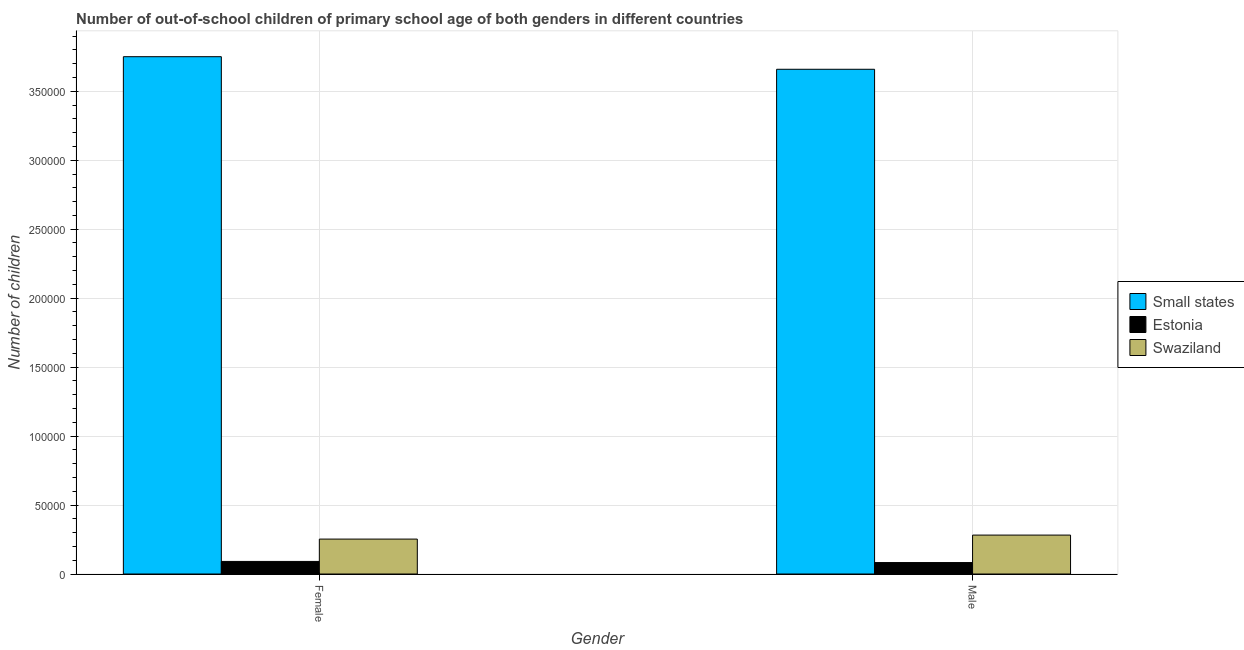How many bars are there on the 2nd tick from the left?
Your response must be concise. 3. How many bars are there on the 1st tick from the right?
Offer a very short reply. 3. What is the label of the 1st group of bars from the left?
Provide a succinct answer. Female. What is the number of male out-of-school students in Small states?
Provide a succinct answer. 3.66e+05. Across all countries, what is the maximum number of female out-of-school students?
Ensure brevity in your answer.  3.75e+05. Across all countries, what is the minimum number of female out-of-school students?
Offer a terse response. 9112. In which country was the number of female out-of-school students maximum?
Your response must be concise. Small states. In which country was the number of female out-of-school students minimum?
Offer a very short reply. Estonia. What is the total number of female out-of-school students in the graph?
Your response must be concise. 4.10e+05. What is the difference between the number of male out-of-school students in Estonia and that in Small states?
Your answer should be compact. -3.58e+05. What is the difference between the number of female out-of-school students in Swaziland and the number of male out-of-school students in Estonia?
Your answer should be compact. 1.70e+04. What is the average number of female out-of-school students per country?
Your answer should be very brief. 1.37e+05. What is the difference between the number of male out-of-school students and number of female out-of-school students in Estonia?
Provide a short and direct response. -815. What is the ratio of the number of male out-of-school students in Small states to that in Estonia?
Keep it short and to the point. 44.11. Is the number of male out-of-school students in Estonia less than that in Swaziland?
Make the answer very short. Yes. In how many countries, is the number of male out-of-school students greater than the average number of male out-of-school students taken over all countries?
Provide a succinct answer. 1. What does the 1st bar from the left in Female represents?
Your answer should be very brief. Small states. What does the 3rd bar from the right in Male represents?
Provide a succinct answer. Small states. How many countries are there in the graph?
Your answer should be very brief. 3. What is the difference between two consecutive major ticks on the Y-axis?
Offer a very short reply. 5.00e+04. Does the graph contain grids?
Ensure brevity in your answer.  Yes. How are the legend labels stacked?
Offer a very short reply. Vertical. What is the title of the graph?
Offer a terse response. Number of out-of-school children of primary school age of both genders in different countries. Does "Pakistan" appear as one of the legend labels in the graph?
Give a very brief answer. No. What is the label or title of the X-axis?
Offer a very short reply. Gender. What is the label or title of the Y-axis?
Offer a terse response. Number of children. What is the Number of children of Small states in Female?
Provide a succinct answer. 3.75e+05. What is the Number of children of Estonia in Female?
Keep it short and to the point. 9112. What is the Number of children in Swaziland in Female?
Provide a short and direct response. 2.53e+04. What is the Number of children in Small states in Male?
Make the answer very short. 3.66e+05. What is the Number of children in Estonia in Male?
Keep it short and to the point. 8297. What is the Number of children of Swaziland in Male?
Offer a very short reply. 2.82e+04. Across all Gender, what is the maximum Number of children in Small states?
Ensure brevity in your answer.  3.75e+05. Across all Gender, what is the maximum Number of children in Estonia?
Your answer should be very brief. 9112. Across all Gender, what is the maximum Number of children in Swaziland?
Your response must be concise. 2.82e+04. Across all Gender, what is the minimum Number of children in Small states?
Keep it short and to the point. 3.66e+05. Across all Gender, what is the minimum Number of children of Estonia?
Keep it short and to the point. 8297. Across all Gender, what is the minimum Number of children in Swaziland?
Make the answer very short. 2.53e+04. What is the total Number of children of Small states in the graph?
Provide a short and direct response. 7.41e+05. What is the total Number of children of Estonia in the graph?
Make the answer very short. 1.74e+04. What is the total Number of children of Swaziland in the graph?
Offer a very short reply. 5.35e+04. What is the difference between the Number of children of Small states in Female and that in Male?
Give a very brief answer. 9123. What is the difference between the Number of children of Estonia in Female and that in Male?
Your response must be concise. 815. What is the difference between the Number of children of Swaziland in Female and that in Male?
Provide a succinct answer. -2902. What is the difference between the Number of children of Small states in Female and the Number of children of Estonia in Male?
Your response must be concise. 3.67e+05. What is the difference between the Number of children of Small states in Female and the Number of children of Swaziland in Male?
Give a very brief answer. 3.47e+05. What is the difference between the Number of children of Estonia in Female and the Number of children of Swaziland in Male?
Give a very brief answer. -1.91e+04. What is the average Number of children in Small states per Gender?
Your answer should be compact. 3.71e+05. What is the average Number of children of Estonia per Gender?
Your answer should be compact. 8704.5. What is the average Number of children of Swaziland per Gender?
Your answer should be compact. 2.68e+04. What is the difference between the Number of children of Small states and Number of children of Estonia in Female?
Provide a short and direct response. 3.66e+05. What is the difference between the Number of children of Small states and Number of children of Swaziland in Female?
Your response must be concise. 3.50e+05. What is the difference between the Number of children of Estonia and Number of children of Swaziland in Female?
Keep it short and to the point. -1.62e+04. What is the difference between the Number of children of Small states and Number of children of Estonia in Male?
Your answer should be compact. 3.58e+05. What is the difference between the Number of children in Small states and Number of children in Swaziland in Male?
Your response must be concise. 3.38e+05. What is the difference between the Number of children of Estonia and Number of children of Swaziland in Male?
Offer a terse response. -1.99e+04. What is the ratio of the Number of children of Small states in Female to that in Male?
Provide a short and direct response. 1.02. What is the ratio of the Number of children of Estonia in Female to that in Male?
Offer a very short reply. 1.1. What is the ratio of the Number of children in Swaziland in Female to that in Male?
Keep it short and to the point. 0.9. What is the difference between the highest and the second highest Number of children in Small states?
Provide a succinct answer. 9123. What is the difference between the highest and the second highest Number of children of Estonia?
Your answer should be compact. 815. What is the difference between the highest and the second highest Number of children in Swaziland?
Your response must be concise. 2902. What is the difference between the highest and the lowest Number of children in Small states?
Keep it short and to the point. 9123. What is the difference between the highest and the lowest Number of children in Estonia?
Provide a succinct answer. 815. What is the difference between the highest and the lowest Number of children of Swaziland?
Offer a terse response. 2902. 